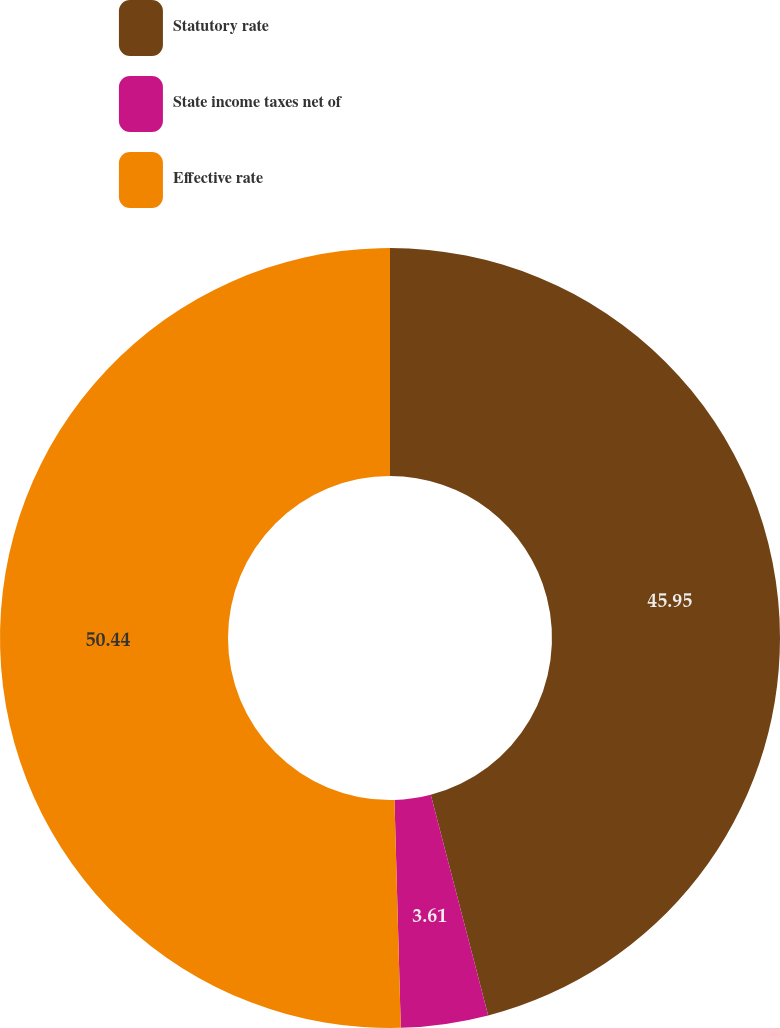Convert chart to OTSL. <chart><loc_0><loc_0><loc_500><loc_500><pie_chart><fcel>Statutory rate<fcel>State income taxes net of<fcel>Effective rate<nl><fcel>45.95%<fcel>3.61%<fcel>50.44%<nl></chart> 